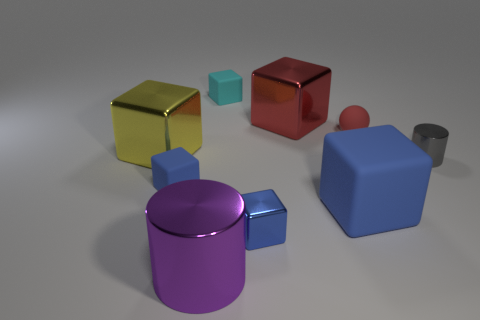There is a big object that is behind the ball; does it have the same color as the tiny matte ball?
Provide a succinct answer. Yes. What color is the cylinder that is left of the big rubber thing?
Your answer should be compact. Purple. What number of rubber things are large objects or purple cylinders?
Offer a very short reply. 1. There is a small blue object behind the matte block that is right of the tiny cyan rubber thing; what is its material?
Give a very brief answer. Rubber. What material is the other small block that is the same color as the small metal cube?
Provide a short and direct response. Rubber. The tiny shiny cube is what color?
Your answer should be very brief. Blue. There is a blue rubber object that is right of the red metal thing; is there a blue metallic thing in front of it?
Provide a succinct answer. Yes. What is the red cube made of?
Your answer should be compact. Metal. Is the small blue object that is on the left side of the large purple metal object made of the same material as the cylinder to the left of the tiny red rubber sphere?
Offer a very short reply. No. Is there anything else that is the same color as the big cylinder?
Give a very brief answer. No. 